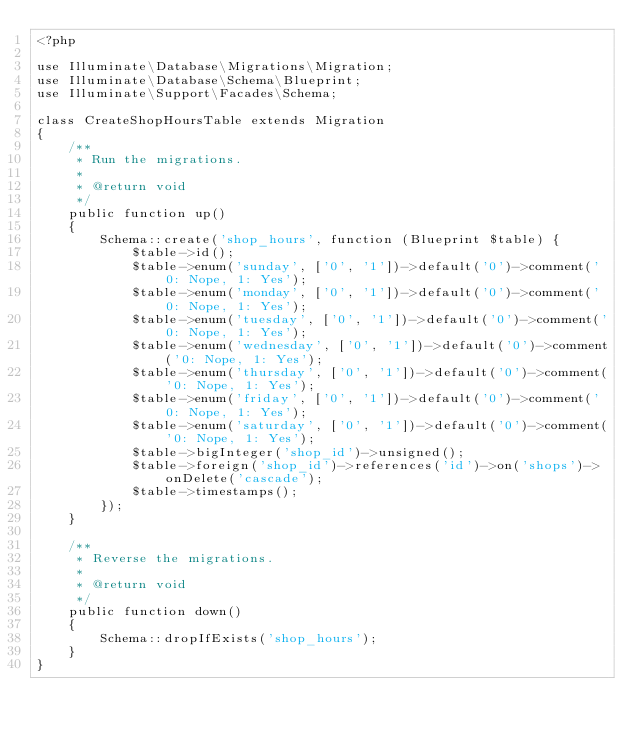<code> <loc_0><loc_0><loc_500><loc_500><_PHP_><?php

use Illuminate\Database\Migrations\Migration;
use Illuminate\Database\Schema\Blueprint;
use Illuminate\Support\Facades\Schema;

class CreateShopHoursTable extends Migration
{
    /**
     * Run the migrations.
     *
     * @return void
     */
    public function up()
    {
        Schema::create('shop_hours', function (Blueprint $table) {
            $table->id();
            $table->enum('sunday', ['0', '1'])->default('0')->comment('0: Nope, 1: Yes');
            $table->enum('monday', ['0', '1'])->default('0')->comment('0: Nope, 1: Yes');
            $table->enum('tuesday', ['0', '1'])->default('0')->comment('0: Nope, 1: Yes');
            $table->enum('wednesday', ['0', '1'])->default('0')->comment('0: Nope, 1: Yes');
            $table->enum('thursday', ['0', '1'])->default('0')->comment('0: Nope, 1: Yes');
            $table->enum('friday', ['0', '1'])->default('0')->comment('0: Nope, 1: Yes');
            $table->enum('saturday', ['0', '1'])->default('0')->comment('0: Nope, 1: Yes');
            $table->bigInteger('shop_id')->unsigned();
            $table->foreign('shop_id')->references('id')->on('shops')->onDelete('cascade');
            $table->timestamps();
        });
    }

    /**
     * Reverse the migrations.
     *
     * @return void
     */
    public function down()
    {
        Schema::dropIfExists('shop_hours');
    }
}
</code> 